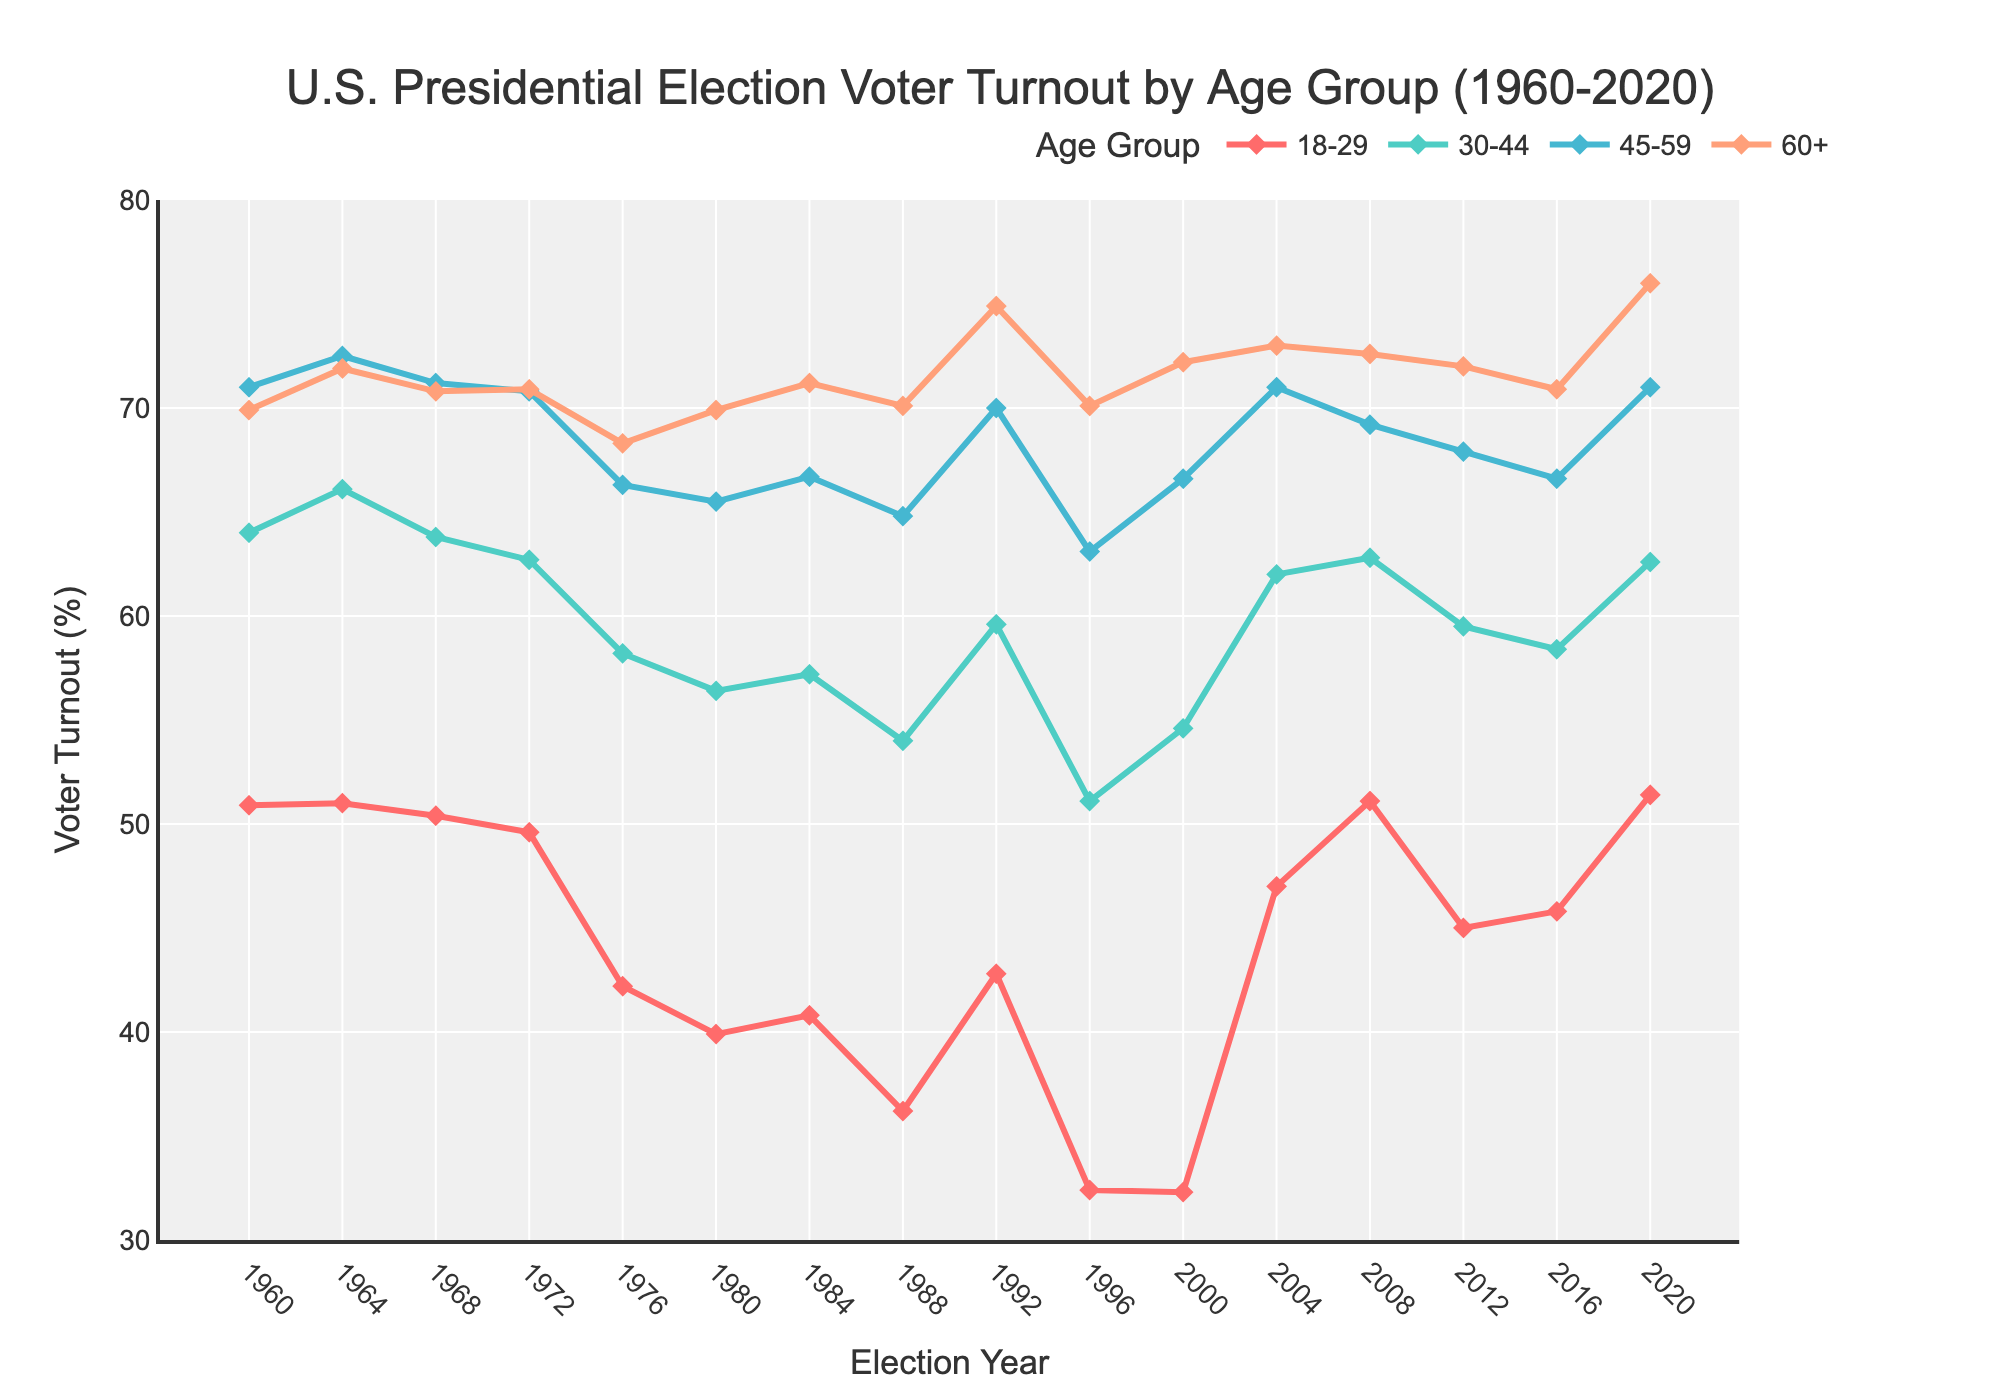What's the voter turnout for the 18-29 age group in 2020 compared to 1960? In 1960, the voter turnout for the 18-29 age group was 50.9%, while in 2020 it was 51.4%. By comparing the two values, you can see that the turnout slightly increased by 0.5 percentage points.
Answer: 51.4% vs. 50.9% Which age group had the highest voter turnout in 2008? To find the highest voter turnout in 2008, look at the values for all age groups in that year. The turnout rates are: 18-29 (51.1%), 30-44 (62.8%), 45-59 (69.2%), and 60+ (72.6%). The 60+ age group has the highest turnout.
Answer: 60+ What's the overall trend in voter turnout for the 30-44 age group from 1960 to 2020? From 1960 to 2020, the voter turnout for the 30-44 age group generally decreased until the mid-1990s and then showed fluctuations with some recovery in the 2000s. However, it never returned to the high levels of the 1960s.
Answer: Decreasing trend with fluctuations By how much did the voter turnout for the 45-59 age group change from 1988 to 1992? In 1988, the voter turnout for the 45-59 age group was 64.8%, and it increased to 70.0% in 1992. The change is calculated as 70.0% - 64.8%, which is 5.2 percentage points.
Answer: 5.2 percentage points What is the difference in voter turnout between the 18-29 and 60+ age groups in 2016? In 2016, the voter turnout for the 18-29 age group was 45.8%, and for the 60+ age group, it was 70.9%. The difference is calculated as 70.9% - 45.8%, which is 25.1 percentage points.
Answer: 25.1 percentage points What is the average voter turnout for the 60+ age group over the entire period? To find the average turnout, add the voter turnout percentages for the 60+ age group for all years and then divide by the number of years. The turnout rates are: 69.9, 71.9, 70.8, 70.9, 68.3, 69.9, 71.2, 70.1, 74.9, 70.1, 72.2, 73.0, 72.6, 72.0, 70.9, 76.0. The sum is 1164.8, and there are 16 data points, so the average is 1164.8 / 16 = 72.8%.
Answer: 72.8% What trend can be observed in voter turnout for the 18-29 age group from 2000 to 2020? For the 18-29 age group, voter turnout increased significantly from 2000 to 2004, then peaked in 2008, decreased in 2012 and 2016, and finally rose again in 2020. This shows a general increasing trend with fluctuations.
Answer: Increasing trend with fluctuations In which year did the 45-59 age group reach the highest voter turnout, and what was the turnout? The 45-59 age group reached its highest voter turnout in 2004 with a turnout rate of 71.0%.
Answer: 2004, 71.0% Compare the voter turnout trends for the 30-44 and 45-59 age groups between 1996 and 2004. For the 30-44 age group, voter turnout increased from 51.1% in 1996 to 62.0% in 2004. For the 45-59 age group, turnout also increased from 63.1% in 1996 to 71.0% in 2004. Both age groups showed a significant increase in voter turnout during this period.
Answer: Both increased significantly 